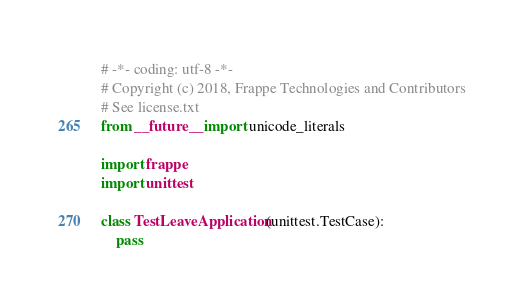<code> <loc_0><loc_0><loc_500><loc_500><_Python_># -*- coding: utf-8 -*-
# Copyright (c) 2018, Frappe Technologies and Contributors
# See license.txt
from __future__ import unicode_literals

import frappe
import unittest

class TestLeaveApplication(unittest.TestCase):
	pass
</code> 